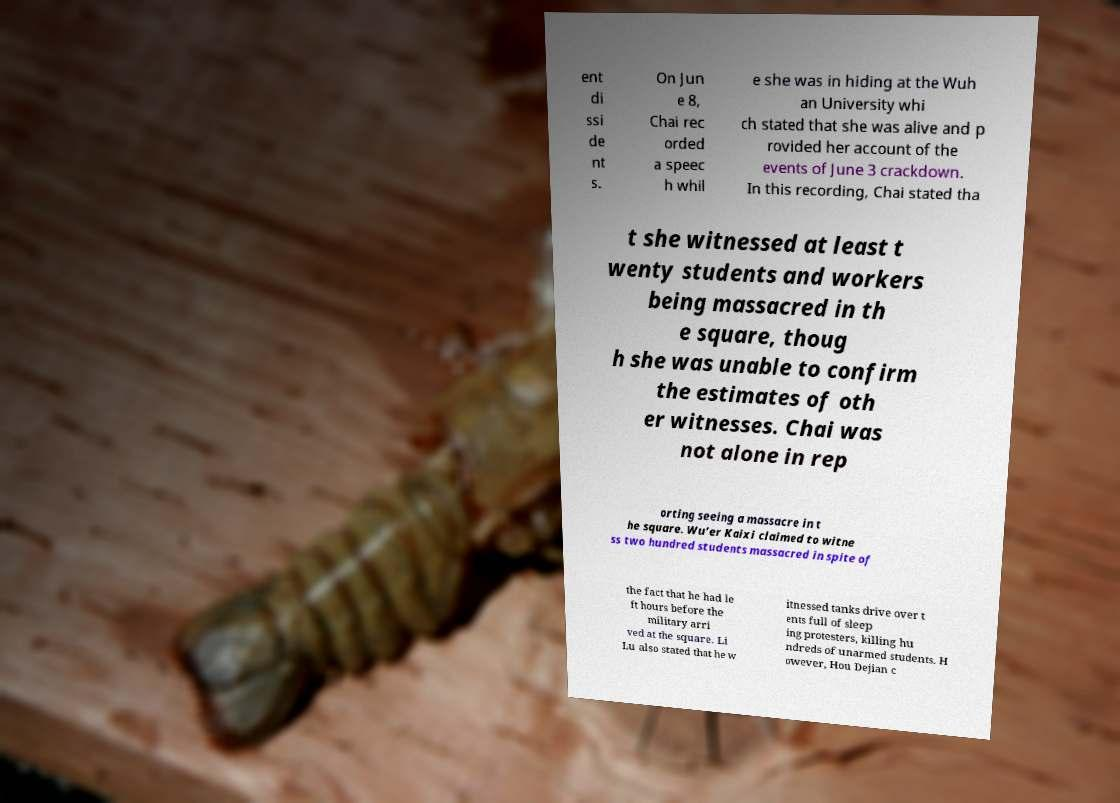There's text embedded in this image that I need extracted. Can you transcribe it verbatim? ent di ssi de nt s. On Jun e 8, Chai rec orded a speec h whil e she was in hiding at the Wuh an University whi ch stated that she was alive and p rovided her account of the events of June 3 crackdown. In this recording, Chai stated tha t she witnessed at least t wenty students and workers being massacred in th e square, thoug h she was unable to confirm the estimates of oth er witnesses. Chai was not alone in rep orting seeing a massacre in t he square. Wu’er Kaixi claimed to witne ss two hundred students massacred in spite of the fact that he had le ft hours before the military arri ved at the square. Li Lu also stated that he w itnessed tanks drive over t ents full of sleep ing protesters, killing hu ndreds of unarmed students. H owever, Hou Dejian c 